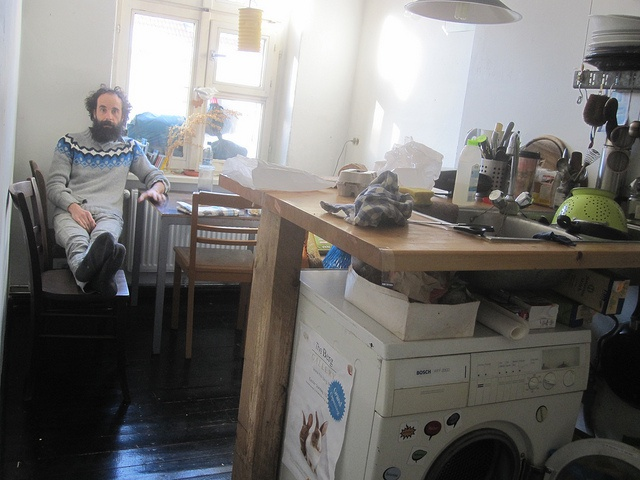Describe the objects in this image and their specific colors. I can see people in lightgray, darkgray, gray, and black tones, chair in lightgray, black, gray, and darkgray tones, chair in lightgray, gray, black, and darkgray tones, dining table in lightgray, gray, black, and darkgray tones, and bowl in lightgray, darkgreen, black, olive, and gray tones in this image. 